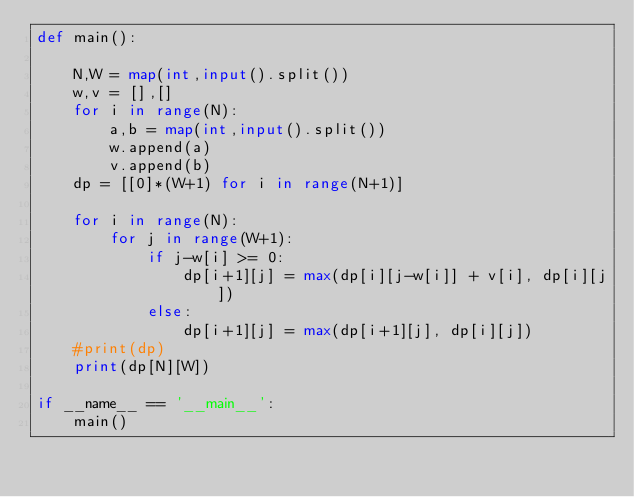<code> <loc_0><loc_0><loc_500><loc_500><_Python_>def main():
    
    N,W = map(int,input().split())
    w,v = [],[]
    for i in range(N):
        a,b = map(int,input().split())
        w.append(a)
        v.append(b)
    dp = [[0]*(W+1) for i in range(N+1)]

    for i in range(N):
        for j in range(W+1):
            if j-w[i] >= 0:
                dp[i+1][j] = max(dp[i][j-w[i]] + v[i], dp[i][j])
            else:
                dp[i+1][j] = max(dp[i+1][j], dp[i][j])
    #print(dp)
    print(dp[N][W])

if __name__ == '__main__':
    main()</code> 